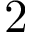Convert formula to latex. <formula><loc_0><loc_0><loc_500><loc_500>2</formula> 